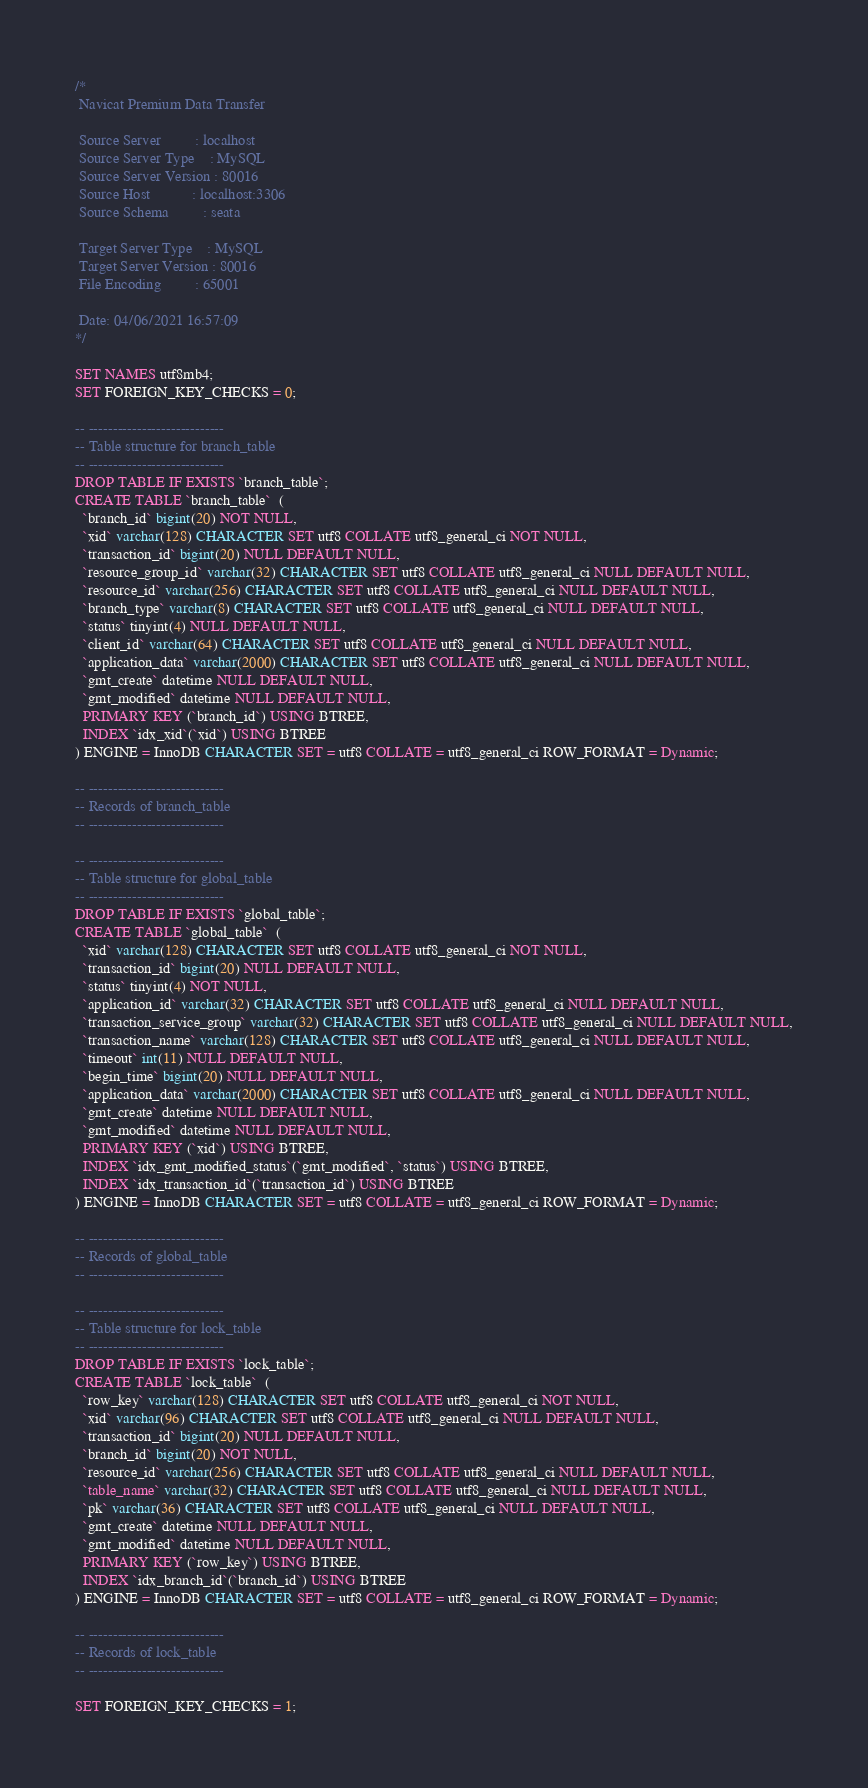Convert code to text. <code><loc_0><loc_0><loc_500><loc_500><_SQL_>/*
 Navicat Premium Data Transfer

 Source Server         : localhost
 Source Server Type    : MySQL
 Source Server Version : 80016
 Source Host           : localhost:3306
 Source Schema         : seata

 Target Server Type    : MySQL
 Target Server Version : 80016
 File Encoding         : 65001

 Date: 04/06/2021 16:57:09
*/

SET NAMES utf8mb4;
SET FOREIGN_KEY_CHECKS = 0;

-- ----------------------------
-- Table structure for branch_table
-- ----------------------------
DROP TABLE IF EXISTS `branch_table`;
CREATE TABLE `branch_table`  (
  `branch_id` bigint(20) NOT NULL,
  `xid` varchar(128) CHARACTER SET utf8 COLLATE utf8_general_ci NOT NULL,
  `transaction_id` bigint(20) NULL DEFAULT NULL,
  `resource_group_id` varchar(32) CHARACTER SET utf8 COLLATE utf8_general_ci NULL DEFAULT NULL,
  `resource_id` varchar(256) CHARACTER SET utf8 COLLATE utf8_general_ci NULL DEFAULT NULL,
  `branch_type` varchar(8) CHARACTER SET utf8 COLLATE utf8_general_ci NULL DEFAULT NULL,
  `status` tinyint(4) NULL DEFAULT NULL,
  `client_id` varchar(64) CHARACTER SET utf8 COLLATE utf8_general_ci NULL DEFAULT NULL,
  `application_data` varchar(2000) CHARACTER SET utf8 COLLATE utf8_general_ci NULL DEFAULT NULL,
  `gmt_create` datetime NULL DEFAULT NULL,
  `gmt_modified` datetime NULL DEFAULT NULL,
  PRIMARY KEY (`branch_id`) USING BTREE,
  INDEX `idx_xid`(`xid`) USING BTREE
) ENGINE = InnoDB CHARACTER SET = utf8 COLLATE = utf8_general_ci ROW_FORMAT = Dynamic;

-- ----------------------------
-- Records of branch_table
-- ----------------------------

-- ----------------------------
-- Table structure for global_table
-- ----------------------------
DROP TABLE IF EXISTS `global_table`;
CREATE TABLE `global_table`  (
  `xid` varchar(128) CHARACTER SET utf8 COLLATE utf8_general_ci NOT NULL,
  `transaction_id` bigint(20) NULL DEFAULT NULL,
  `status` tinyint(4) NOT NULL,
  `application_id` varchar(32) CHARACTER SET utf8 COLLATE utf8_general_ci NULL DEFAULT NULL,
  `transaction_service_group` varchar(32) CHARACTER SET utf8 COLLATE utf8_general_ci NULL DEFAULT NULL,
  `transaction_name` varchar(128) CHARACTER SET utf8 COLLATE utf8_general_ci NULL DEFAULT NULL,
  `timeout` int(11) NULL DEFAULT NULL,
  `begin_time` bigint(20) NULL DEFAULT NULL,
  `application_data` varchar(2000) CHARACTER SET utf8 COLLATE utf8_general_ci NULL DEFAULT NULL,
  `gmt_create` datetime NULL DEFAULT NULL,
  `gmt_modified` datetime NULL DEFAULT NULL,
  PRIMARY KEY (`xid`) USING BTREE,
  INDEX `idx_gmt_modified_status`(`gmt_modified`, `status`) USING BTREE,
  INDEX `idx_transaction_id`(`transaction_id`) USING BTREE
) ENGINE = InnoDB CHARACTER SET = utf8 COLLATE = utf8_general_ci ROW_FORMAT = Dynamic;

-- ----------------------------
-- Records of global_table
-- ----------------------------

-- ----------------------------
-- Table structure for lock_table
-- ----------------------------
DROP TABLE IF EXISTS `lock_table`;
CREATE TABLE `lock_table`  (
  `row_key` varchar(128) CHARACTER SET utf8 COLLATE utf8_general_ci NOT NULL,
  `xid` varchar(96) CHARACTER SET utf8 COLLATE utf8_general_ci NULL DEFAULT NULL,
  `transaction_id` bigint(20) NULL DEFAULT NULL,
  `branch_id` bigint(20) NOT NULL,
  `resource_id` varchar(256) CHARACTER SET utf8 COLLATE utf8_general_ci NULL DEFAULT NULL,
  `table_name` varchar(32) CHARACTER SET utf8 COLLATE utf8_general_ci NULL DEFAULT NULL,
  `pk` varchar(36) CHARACTER SET utf8 COLLATE utf8_general_ci NULL DEFAULT NULL,
  `gmt_create` datetime NULL DEFAULT NULL,
  `gmt_modified` datetime NULL DEFAULT NULL,
  PRIMARY KEY (`row_key`) USING BTREE,
  INDEX `idx_branch_id`(`branch_id`) USING BTREE
) ENGINE = InnoDB CHARACTER SET = utf8 COLLATE = utf8_general_ci ROW_FORMAT = Dynamic;

-- ----------------------------
-- Records of lock_table
-- ----------------------------

SET FOREIGN_KEY_CHECKS = 1;
</code> 